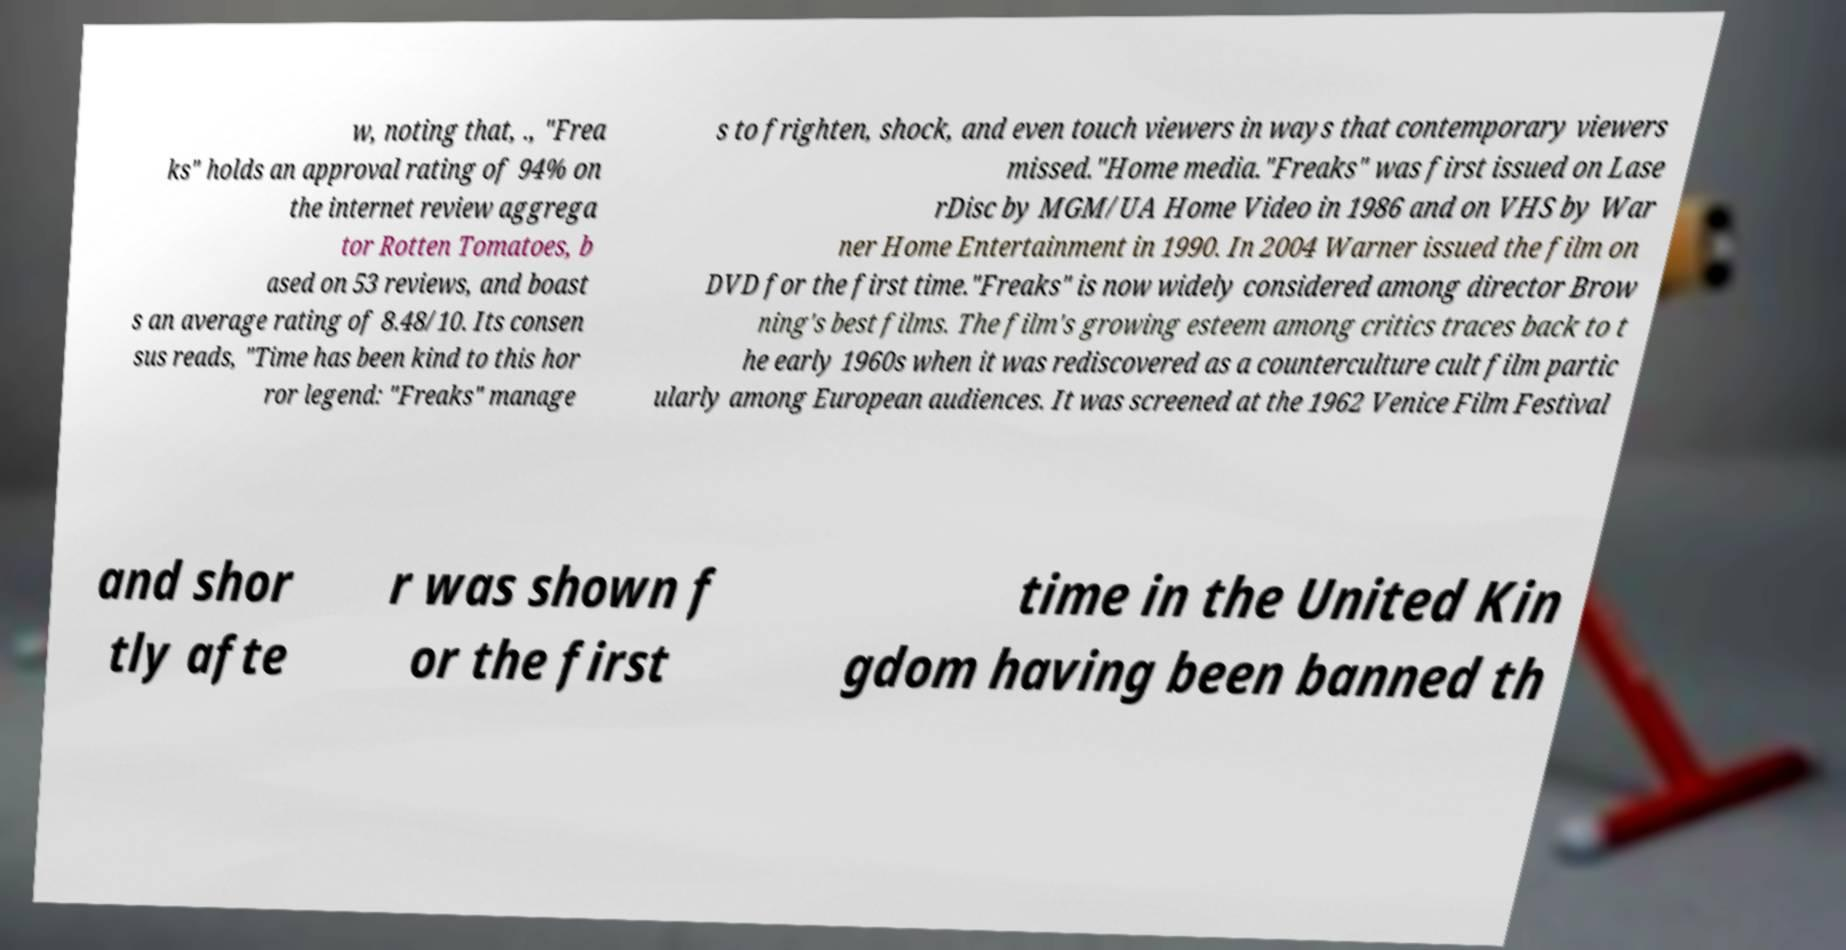There's text embedded in this image that I need extracted. Can you transcribe it verbatim? w, noting that, ., "Frea ks" holds an approval rating of 94% on the internet review aggrega tor Rotten Tomatoes, b ased on 53 reviews, and boast s an average rating of 8.48/10. Its consen sus reads, "Time has been kind to this hor ror legend: "Freaks" manage s to frighten, shock, and even touch viewers in ways that contemporary viewers missed."Home media."Freaks" was first issued on Lase rDisc by MGM/UA Home Video in 1986 and on VHS by War ner Home Entertainment in 1990. In 2004 Warner issued the film on DVD for the first time."Freaks" is now widely considered among director Brow ning's best films. The film's growing esteem among critics traces back to t he early 1960s when it was rediscovered as a counterculture cult film partic ularly among European audiences. It was screened at the 1962 Venice Film Festival and shor tly afte r was shown f or the first time in the United Kin gdom having been banned th 